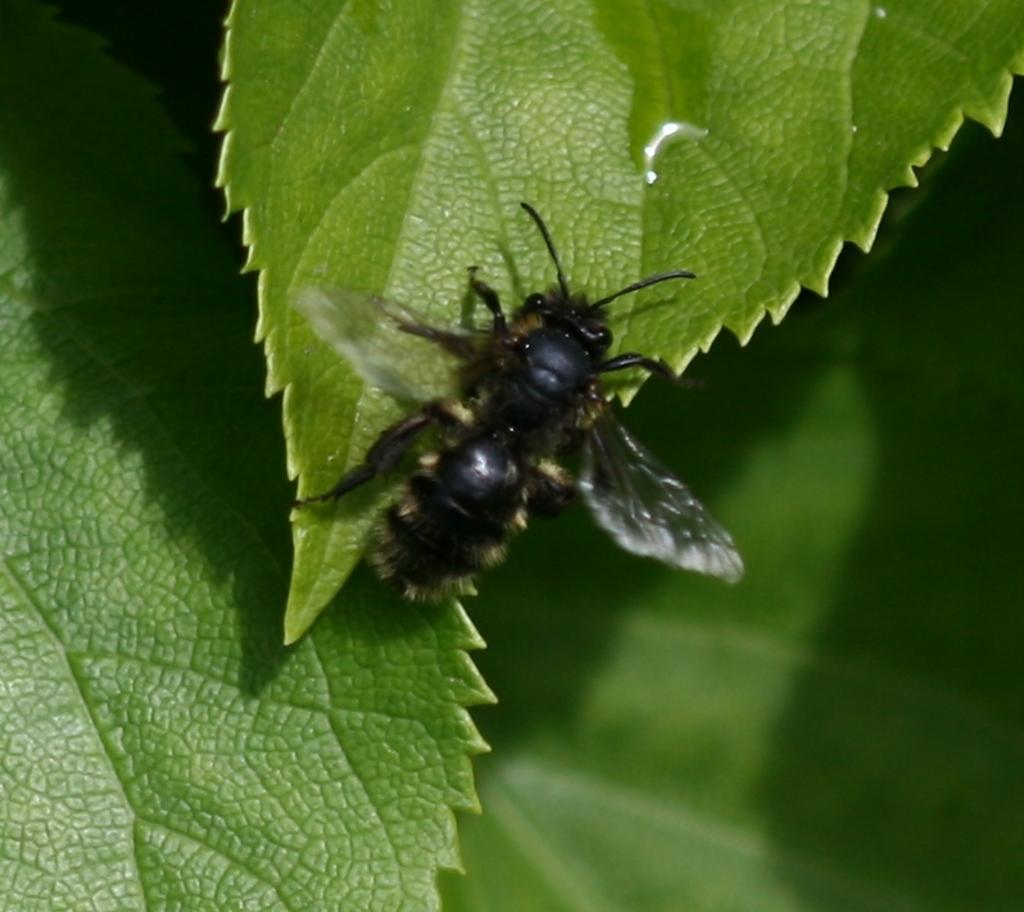What is present on the leaf in the image? There is an insect on a leaf in the image. What can be seen in the background of the image? There are leaves visible in the background of the image. What type of breakfast is being served on the roof in the image? There is no mention of breakfast or a roof in the image; it features an insect on a leaf and leaves in the background. 